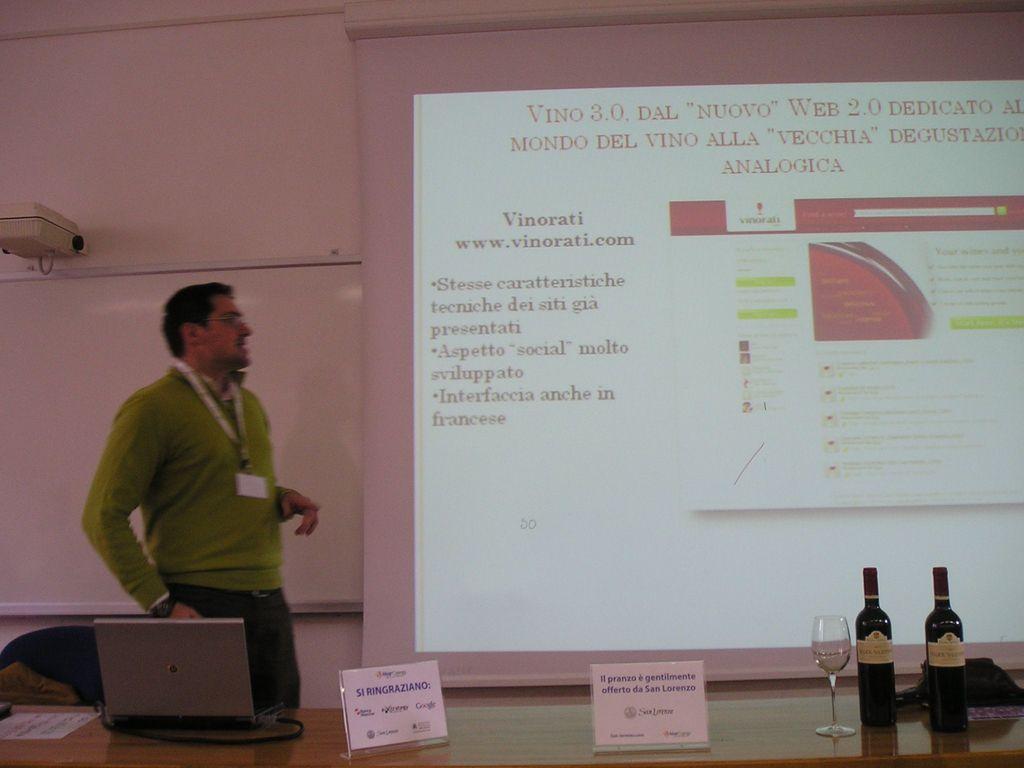Please provide a concise description of this image. In this picture there is a man on the left side of the image, there are bottles and a laptop on the table at the bottom side of the image and there is a projector screen in the background area of the image. 